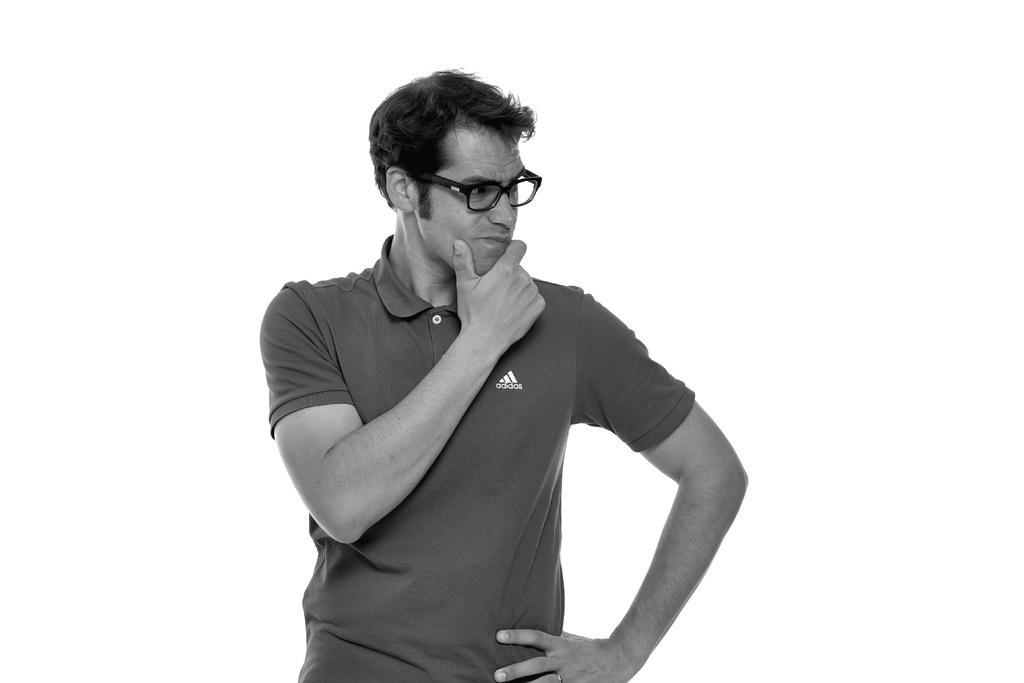Please provide a concise description of this image. In this image I can see a person standing wearing spectacles and the image is in black and white. 